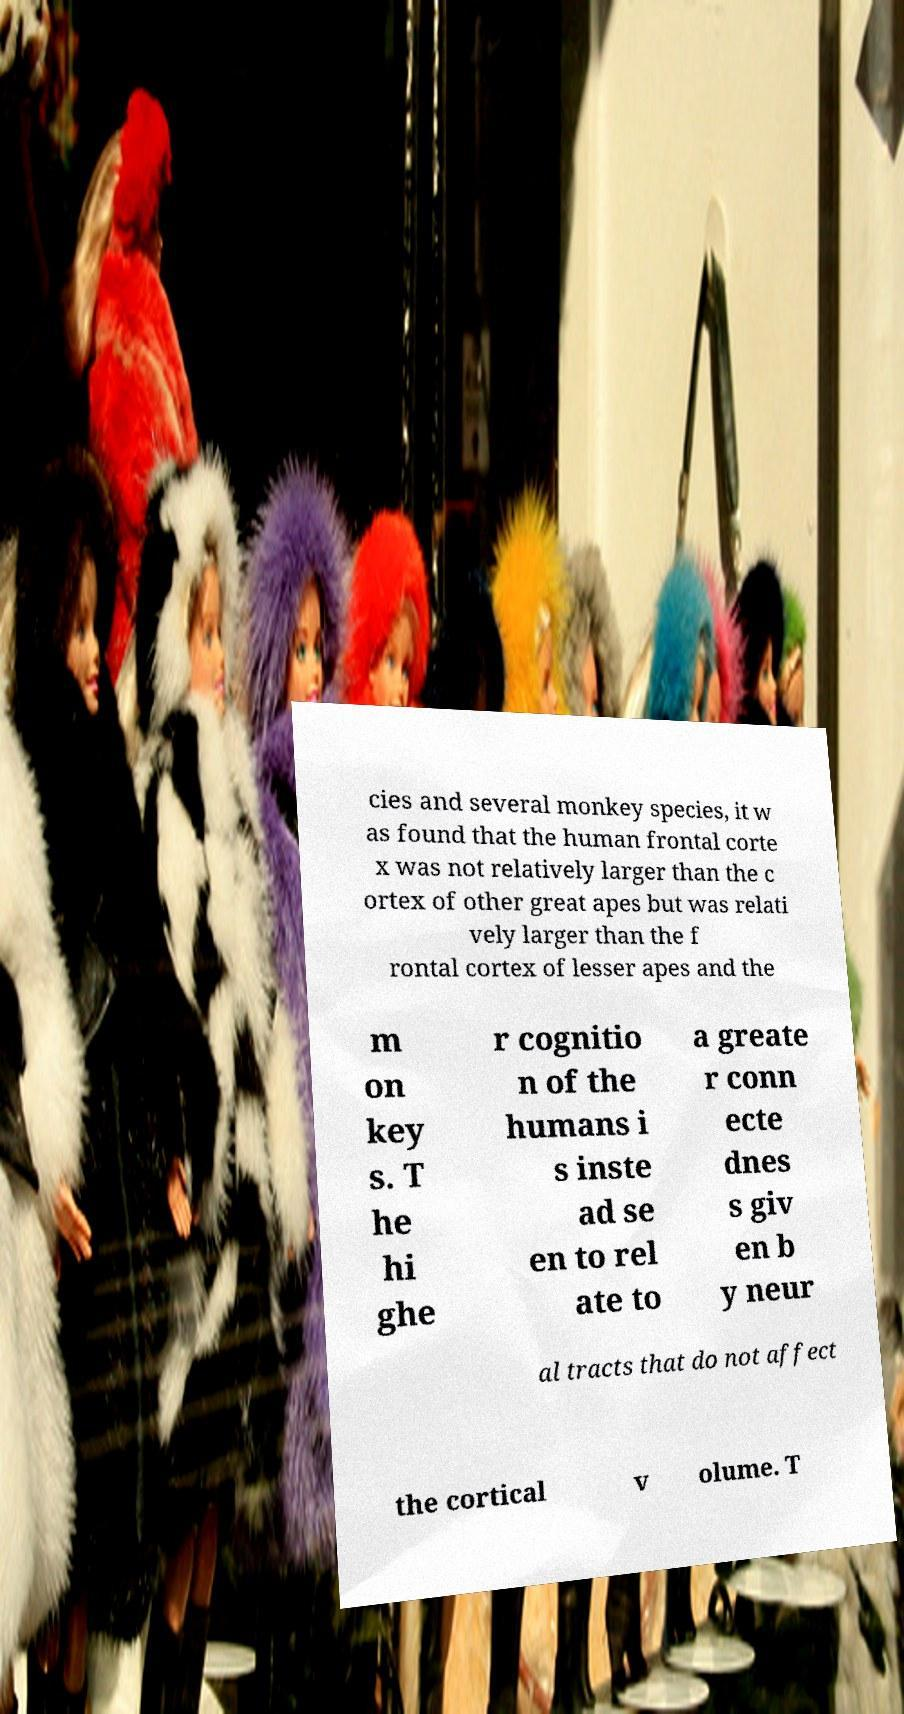Can you read and provide the text displayed in the image?This photo seems to have some interesting text. Can you extract and type it out for me? cies and several monkey species, it w as found that the human frontal corte x was not relatively larger than the c ortex of other great apes but was relati vely larger than the f rontal cortex of lesser apes and the m on key s. T he hi ghe r cognitio n of the humans i s inste ad se en to rel ate to a greate r conn ecte dnes s giv en b y neur al tracts that do not affect the cortical v olume. T 